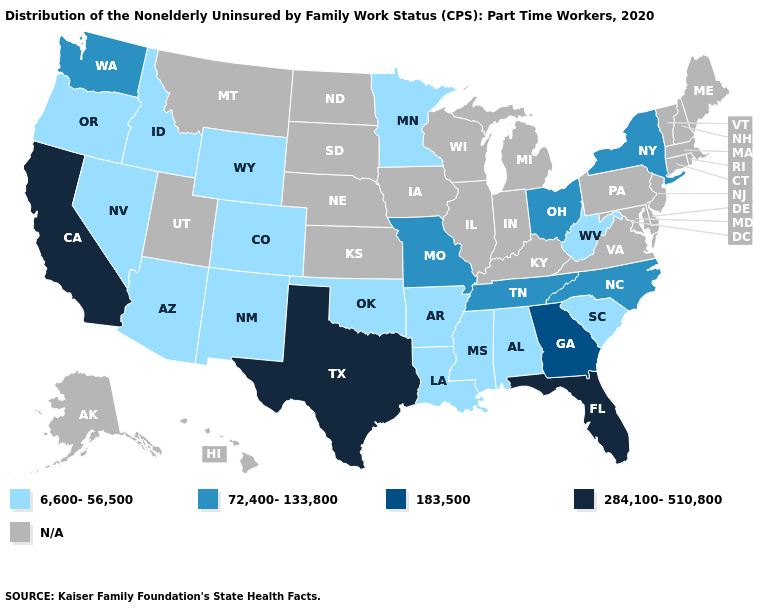What is the value of Utah?
Concise answer only. N/A. What is the value of Nevada?
Give a very brief answer. 6,600-56,500. What is the lowest value in the West?
Answer briefly. 6,600-56,500. Name the states that have a value in the range 6,600-56,500?
Keep it brief. Alabama, Arizona, Arkansas, Colorado, Idaho, Louisiana, Minnesota, Mississippi, Nevada, New Mexico, Oklahoma, Oregon, South Carolina, West Virginia, Wyoming. Name the states that have a value in the range 72,400-133,800?
Answer briefly. Missouri, New York, North Carolina, Ohio, Tennessee, Washington. What is the value of Texas?
Answer briefly. 284,100-510,800. Which states have the lowest value in the USA?
Concise answer only. Alabama, Arizona, Arkansas, Colorado, Idaho, Louisiana, Minnesota, Mississippi, Nevada, New Mexico, Oklahoma, Oregon, South Carolina, West Virginia, Wyoming. Among the states that border Iowa , does Minnesota have the lowest value?
Write a very short answer. Yes. What is the value of Utah?
Be succinct. N/A. Name the states that have a value in the range 6,600-56,500?
Answer briefly. Alabama, Arizona, Arkansas, Colorado, Idaho, Louisiana, Minnesota, Mississippi, Nevada, New Mexico, Oklahoma, Oregon, South Carolina, West Virginia, Wyoming. What is the value of Connecticut?
Concise answer only. N/A. Does Texas have the lowest value in the USA?
Be succinct. No. Does Washington have the lowest value in the USA?
Give a very brief answer. No. 